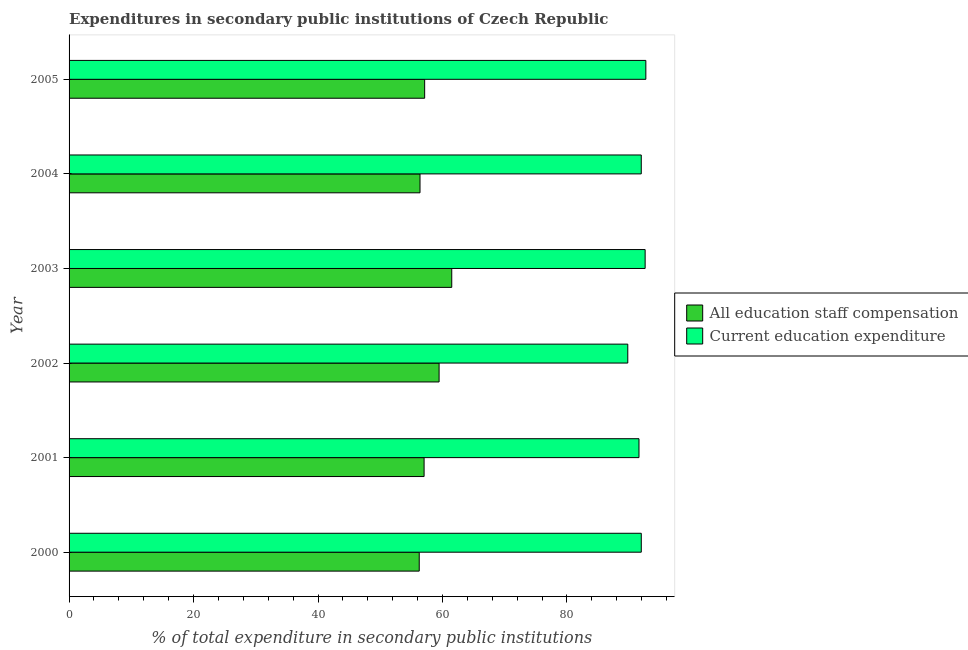How many groups of bars are there?
Your answer should be compact. 6. Are the number of bars per tick equal to the number of legend labels?
Give a very brief answer. Yes. How many bars are there on the 3rd tick from the top?
Ensure brevity in your answer.  2. How many bars are there on the 2nd tick from the bottom?
Make the answer very short. 2. What is the label of the 4th group of bars from the top?
Offer a terse response. 2002. What is the expenditure in staff compensation in 2004?
Make the answer very short. 56.39. Across all years, what is the maximum expenditure in staff compensation?
Offer a terse response. 61.49. Across all years, what is the minimum expenditure in education?
Make the answer very short. 89.78. In which year was the expenditure in education maximum?
Keep it short and to the point. 2005. In which year was the expenditure in staff compensation minimum?
Your answer should be compact. 2000. What is the total expenditure in education in the graph?
Provide a short and direct response. 550.51. What is the difference between the expenditure in staff compensation in 2003 and that in 2004?
Ensure brevity in your answer.  5.1. What is the difference between the expenditure in education in 2004 and the expenditure in staff compensation in 2005?
Your response must be concise. 34.81. What is the average expenditure in staff compensation per year?
Ensure brevity in your answer.  57.97. In the year 2002, what is the difference between the expenditure in education and expenditure in staff compensation?
Offer a terse response. 30.32. In how many years, is the expenditure in staff compensation greater than 20 %?
Give a very brief answer. 6. Is the expenditure in staff compensation in 2000 less than that in 2001?
Your answer should be very brief. Yes. Is the difference between the expenditure in staff compensation in 2001 and 2005 greater than the difference between the expenditure in education in 2001 and 2005?
Provide a short and direct response. Yes. What is the difference between the highest and the second highest expenditure in staff compensation?
Your answer should be very brief. 2.04. What is the difference between the highest and the lowest expenditure in staff compensation?
Make the answer very short. 5.22. What does the 2nd bar from the top in 2005 represents?
Make the answer very short. All education staff compensation. What does the 2nd bar from the bottom in 2005 represents?
Your response must be concise. Current education expenditure. Are the values on the major ticks of X-axis written in scientific E-notation?
Provide a succinct answer. No. Does the graph contain any zero values?
Make the answer very short. No. Where does the legend appear in the graph?
Your response must be concise. Center right. How are the legend labels stacked?
Your response must be concise. Vertical. What is the title of the graph?
Provide a succinct answer. Expenditures in secondary public institutions of Czech Republic. Does "Agricultural land" appear as one of the legend labels in the graph?
Provide a succinct answer. No. What is the label or title of the X-axis?
Keep it short and to the point. % of total expenditure in secondary public institutions. What is the label or title of the Y-axis?
Provide a succinct answer. Year. What is the % of total expenditure in secondary public institutions in All education staff compensation in 2000?
Give a very brief answer. 56.27. What is the % of total expenditure in secondary public institutions of Current education expenditure in 2000?
Provide a short and direct response. 91.95. What is the % of total expenditure in secondary public institutions of All education staff compensation in 2001?
Offer a terse response. 57.05. What is the % of total expenditure in secondary public institutions of Current education expenditure in 2001?
Your answer should be very brief. 91.58. What is the % of total expenditure in secondary public institutions in All education staff compensation in 2002?
Keep it short and to the point. 59.46. What is the % of total expenditure in secondary public institutions in Current education expenditure in 2002?
Give a very brief answer. 89.78. What is the % of total expenditure in secondary public institutions in All education staff compensation in 2003?
Ensure brevity in your answer.  61.49. What is the % of total expenditure in secondary public institutions in Current education expenditure in 2003?
Your response must be concise. 92.57. What is the % of total expenditure in secondary public institutions of All education staff compensation in 2004?
Your response must be concise. 56.39. What is the % of total expenditure in secondary public institutions of Current education expenditure in 2004?
Provide a succinct answer. 91.95. What is the % of total expenditure in secondary public institutions of All education staff compensation in 2005?
Make the answer very short. 57.14. What is the % of total expenditure in secondary public institutions of Current education expenditure in 2005?
Your answer should be compact. 92.68. Across all years, what is the maximum % of total expenditure in secondary public institutions of All education staff compensation?
Your answer should be compact. 61.49. Across all years, what is the maximum % of total expenditure in secondary public institutions in Current education expenditure?
Offer a very short reply. 92.68. Across all years, what is the minimum % of total expenditure in secondary public institutions in All education staff compensation?
Your response must be concise. 56.27. Across all years, what is the minimum % of total expenditure in secondary public institutions in Current education expenditure?
Ensure brevity in your answer.  89.78. What is the total % of total expenditure in secondary public institutions in All education staff compensation in the graph?
Ensure brevity in your answer.  347.8. What is the total % of total expenditure in secondary public institutions of Current education expenditure in the graph?
Keep it short and to the point. 550.51. What is the difference between the % of total expenditure in secondary public institutions of All education staff compensation in 2000 and that in 2001?
Your response must be concise. -0.78. What is the difference between the % of total expenditure in secondary public institutions of Current education expenditure in 2000 and that in 2001?
Ensure brevity in your answer.  0.37. What is the difference between the % of total expenditure in secondary public institutions of All education staff compensation in 2000 and that in 2002?
Provide a succinct answer. -3.19. What is the difference between the % of total expenditure in secondary public institutions of Current education expenditure in 2000 and that in 2002?
Provide a succinct answer. 2.17. What is the difference between the % of total expenditure in secondary public institutions in All education staff compensation in 2000 and that in 2003?
Keep it short and to the point. -5.22. What is the difference between the % of total expenditure in secondary public institutions in Current education expenditure in 2000 and that in 2003?
Your response must be concise. -0.62. What is the difference between the % of total expenditure in secondary public institutions of All education staff compensation in 2000 and that in 2004?
Offer a terse response. -0.12. What is the difference between the % of total expenditure in secondary public institutions of Current education expenditure in 2000 and that in 2004?
Offer a very short reply. 0. What is the difference between the % of total expenditure in secondary public institutions of All education staff compensation in 2000 and that in 2005?
Your answer should be compact. -0.87. What is the difference between the % of total expenditure in secondary public institutions in Current education expenditure in 2000 and that in 2005?
Your response must be concise. -0.73. What is the difference between the % of total expenditure in secondary public institutions of All education staff compensation in 2001 and that in 2002?
Your answer should be very brief. -2.41. What is the difference between the % of total expenditure in secondary public institutions in Current education expenditure in 2001 and that in 2002?
Provide a succinct answer. 1.8. What is the difference between the % of total expenditure in secondary public institutions of All education staff compensation in 2001 and that in 2003?
Provide a short and direct response. -4.45. What is the difference between the % of total expenditure in secondary public institutions of Current education expenditure in 2001 and that in 2003?
Ensure brevity in your answer.  -0.99. What is the difference between the % of total expenditure in secondary public institutions of All education staff compensation in 2001 and that in 2004?
Your answer should be compact. 0.65. What is the difference between the % of total expenditure in secondary public institutions in Current education expenditure in 2001 and that in 2004?
Provide a short and direct response. -0.37. What is the difference between the % of total expenditure in secondary public institutions in All education staff compensation in 2001 and that in 2005?
Give a very brief answer. -0.09. What is the difference between the % of total expenditure in secondary public institutions of Current education expenditure in 2001 and that in 2005?
Provide a succinct answer. -1.1. What is the difference between the % of total expenditure in secondary public institutions of All education staff compensation in 2002 and that in 2003?
Give a very brief answer. -2.04. What is the difference between the % of total expenditure in secondary public institutions in Current education expenditure in 2002 and that in 2003?
Provide a short and direct response. -2.79. What is the difference between the % of total expenditure in secondary public institutions of All education staff compensation in 2002 and that in 2004?
Keep it short and to the point. 3.06. What is the difference between the % of total expenditure in secondary public institutions in Current education expenditure in 2002 and that in 2004?
Ensure brevity in your answer.  -2.17. What is the difference between the % of total expenditure in secondary public institutions of All education staff compensation in 2002 and that in 2005?
Provide a succinct answer. 2.32. What is the difference between the % of total expenditure in secondary public institutions in Current education expenditure in 2002 and that in 2005?
Keep it short and to the point. -2.9. What is the difference between the % of total expenditure in secondary public institutions of Current education expenditure in 2003 and that in 2004?
Make the answer very short. 0.62. What is the difference between the % of total expenditure in secondary public institutions of All education staff compensation in 2003 and that in 2005?
Your response must be concise. 4.35. What is the difference between the % of total expenditure in secondary public institutions of Current education expenditure in 2003 and that in 2005?
Ensure brevity in your answer.  -0.11. What is the difference between the % of total expenditure in secondary public institutions in All education staff compensation in 2004 and that in 2005?
Offer a terse response. -0.75. What is the difference between the % of total expenditure in secondary public institutions of Current education expenditure in 2004 and that in 2005?
Give a very brief answer. -0.73. What is the difference between the % of total expenditure in secondary public institutions in All education staff compensation in 2000 and the % of total expenditure in secondary public institutions in Current education expenditure in 2001?
Provide a short and direct response. -35.31. What is the difference between the % of total expenditure in secondary public institutions in All education staff compensation in 2000 and the % of total expenditure in secondary public institutions in Current education expenditure in 2002?
Provide a short and direct response. -33.51. What is the difference between the % of total expenditure in secondary public institutions in All education staff compensation in 2000 and the % of total expenditure in secondary public institutions in Current education expenditure in 2003?
Ensure brevity in your answer.  -36.3. What is the difference between the % of total expenditure in secondary public institutions of All education staff compensation in 2000 and the % of total expenditure in secondary public institutions of Current education expenditure in 2004?
Your answer should be very brief. -35.68. What is the difference between the % of total expenditure in secondary public institutions in All education staff compensation in 2000 and the % of total expenditure in secondary public institutions in Current education expenditure in 2005?
Offer a very short reply. -36.41. What is the difference between the % of total expenditure in secondary public institutions in All education staff compensation in 2001 and the % of total expenditure in secondary public institutions in Current education expenditure in 2002?
Provide a succinct answer. -32.73. What is the difference between the % of total expenditure in secondary public institutions in All education staff compensation in 2001 and the % of total expenditure in secondary public institutions in Current education expenditure in 2003?
Offer a terse response. -35.52. What is the difference between the % of total expenditure in secondary public institutions in All education staff compensation in 2001 and the % of total expenditure in secondary public institutions in Current education expenditure in 2004?
Your answer should be compact. -34.9. What is the difference between the % of total expenditure in secondary public institutions of All education staff compensation in 2001 and the % of total expenditure in secondary public institutions of Current education expenditure in 2005?
Your answer should be very brief. -35.63. What is the difference between the % of total expenditure in secondary public institutions of All education staff compensation in 2002 and the % of total expenditure in secondary public institutions of Current education expenditure in 2003?
Your response must be concise. -33.11. What is the difference between the % of total expenditure in secondary public institutions in All education staff compensation in 2002 and the % of total expenditure in secondary public institutions in Current education expenditure in 2004?
Make the answer very short. -32.49. What is the difference between the % of total expenditure in secondary public institutions in All education staff compensation in 2002 and the % of total expenditure in secondary public institutions in Current education expenditure in 2005?
Your answer should be compact. -33.22. What is the difference between the % of total expenditure in secondary public institutions in All education staff compensation in 2003 and the % of total expenditure in secondary public institutions in Current education expenditure in 2004?
Make the answer very short. -30.45. What is the difference between the % of total expenditure in secondary public institutions of All education staff compensation in 2003 and the % of total expenditure in secondary public institutions of Current education expenditure in 2005?
Ensure brevity in your answer.  -31.19. What is the difference between the % of total expenditure in secondary public institutions of All education staff compensation in 2004 and the % of total expenditure in secondary public institutions of Current education expenditure in 2005?
Make the answer very short. -36.29. What is the average % of total expenditure in secondary public institutions of All education staff compensation per year?
Provide a succinct answer. 57.97. What is the average % of total expenditure in secondary public institutions in Current education expenditure per year?
Offer a terse response. 91.75. In the year 2000, what is the difference between the % of total expenditure in secondary public institutions of All education staff compensation and % of total expenditure in secondary public institutions of Current education expenditure?
Your response must be concise. -35.68. In the year 2001, what is the difference between the % of total expenditure in secondary public institutions in All education staff compensation and % of total expenditure in secondary public institutions in Current education expenditure?
Give a very brief answer. -34.53. In the year 2002, what is the difference between the % of total expenditure in secondary public institutions in All education staff compensation and % of total expenditure in secondary public institutions in Current education expenditure?
Make the answer very short. -30.32. In the year 2003, what is the difference between the % of total expenditure in secondary public institutions of All education staff compensation and % of total expenditure in secondary public institutions of Current education expenditure?
Your answer should be very brief. -31.08. In the year 2004, what is the difference between the % of total expenditure in secondary public institutions of All education staff compensation and % of total expenditure in secondary public institutions of Current education expenditure?
Offer a very short reply. -35.55. In the year 2005, what is the difference between the % of total expenditure in secondary public institutions in All education staff compensation and % of total expenditure in secondary public institutions in Current education expenditure?
Provide a succinct answer. -35.54. What is the ratio of the % of total expenditure in secondary public institutions in All education staff compensation in 2000 to that in 2001?
Your answer should be compact. 0.99. What is the ratio of the % of total expenditure in secondary public institutions of Current education expenditure in 2000 to that in 2001?
Ensure brevity in your answer.  1. What is the ratio of the % of total expenditure in secondary public institutions of All education staff compensation in 2000 to that in 2002?
Ensure brevity in your answer.  0.95. What is the ratio of the % of total expenditure in secondary public institutions of Current education expenditure in 2000 to that in 2002?
Give a very brief answer. 1.02. What is the ratio of the % of total expenditure in secondary public institutions of All education staff compensation in 2000 to that in 2003?
Ensure brevity in your answer.  0.92. What is the ratio of the % of total expenditure in secondary public institutions of Current education expenditure in 2000 to that in 2003?
Give a very brief answer. 0.99. What is the ratio of the % of total expenditure in secondary public institutions in All education staff compensation in 2000 to that in 2004?
Provide a short and direct response. 1. What is the ratio of the % of total expenditure in secondary public institutions in Current education expenditure in 2000 to that in 2004?
Offer a very short reply. 1. What is the ratio of the % of total expenditure in secondary public institutions in All education staff compensation in 2000 to that in 2005?
Offer a terse response. 0.98. What is the ratio of the % of total expenditure in secondary public institutions in All education staff compensation in 2001 to that in 2002?
Make the answer very short. 0.96. What is the ratio of the % of total expenditure in secondary public institutions of Current education expenditure in 2001 to that in 2002?
Provide a succinct answer. 1.02. What is the ratio of the % of total expenditure in secondary public institutions of All education staff compensation in 2001 to that in 2003?
Your answer should be compact. 0.93. What is the ratio of the % of total expenditure in secondary public institutions in Current education expenditure in 2001 to that in 2003?
Keep it short and to the point. 0.99. What is the ratio of the % of total expenditure in secondary public institutions of All education staff compensation in 2001 to that in 2004?
Your answer should be compact. 1.01. What is the ratio of the % of total expenditure in secondary public institutions in All education staff compensation in 2001 to that in 2005?
Your response must be concise. 1. What is the ratio of the % of total expenditure in secondary public institutions of All education staff compensation in 2002 to that in 2003?
Keep it short and to the point. 0.97. What is the ratio of the % of total expenditure in secondary public institutions of Current education expenditure in 2002 to that in 2003?
Your response must be concise. 0.97. What is the ratio of the % of total expenditure in secondary public institutions of All education staff compensation in 2002 to that in 2004?
Provide a succinct answer. 1.05. What is the ratio of the % of total expenditure in secondary public institutions of Current education expenditure in 2002 to that in 2004?
Make the answer very short. 0.98. What is the ratio of the % of total expenditure in secondary public institutions in All education staff compensation in 2002 to that in 2005?
Offer a very short reply. 1.04. What is the ratio of the % of total expenditure in secondary public institutions in Current education expenditure in 2002 to that in 2005?
Offer a very short reply. 0.97. What is the ratio of the % of total expenditure in secondary public institutions of All education staff compensation in 2003 to that in 2004?
Your response must be concise. 1.09. What is the ratio of the % of total expenditure in secondary public institutions in Current education expenditure in 2003 to that in 2004?
Ensure brevity in your answer.  1.01. What is the ratio of the % of total expenditure in secondary public institutions of All education staff compensation in 2003 to that in 2005?
Your answer should be very brief. 1.08. What is the ratio of the % of total expenditure in secondary public institutions in All education staff compensation in 2004 to that in 2005?
Offer a terse response. 0.99. What is the difference between the highest and the second highest % of total expenditure in secondary public institutions in All education staff compensation?
Your response must be concise. 2.04. What is the difference between the highest and the second highest % of total expenditure in secondary public institutions in Current education expenditure?
Keep it short and to the point. 0.11. What is the difference between the highest and the lowest % of total expenditure in secondary public institutions in All education staff compensation?
Your response must be concise. 5.22. What is the difference between the highest and the lowest % of total expenditure in secondary public institutions of Current education expenditure?
Your answer should be compact. 2.9. 